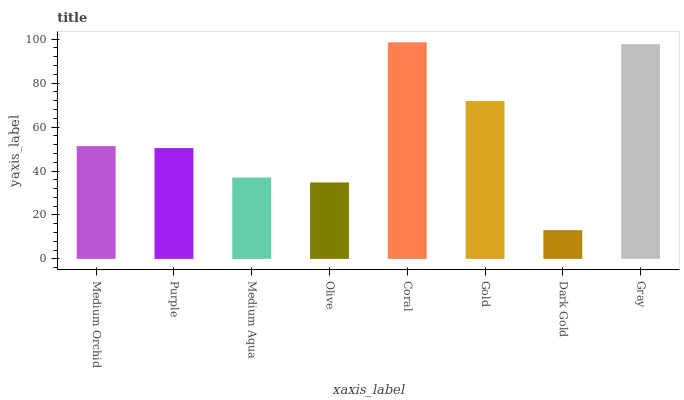Is Dark Gold the minimum?
Answer yes or no. Yes. Is Coral the maximum?
Answer yes or no. Yes. Is Purple the minimum?
Answer yes or no. No. Is Purple the maximum?
Answer yes or no. No. Is Medium Orchid greater than Purple?
Answer yes or no. Yes. Is Purple less than Medium Orchid?
Answer yes or no. Yes. Is Purple greater than Medium Orchid?
Answer yes or no. No. Is Medium Orchid less than Purple?
Answer yes or no. No. Is Medium Orchid the high median?
Answer yes or no. Yes. Is Purple the low median?
Answer yes or no. Yes. Is Gold the high median?
Answer yes or no. No. Is Coral the low median?
Answer yes or no. No. 